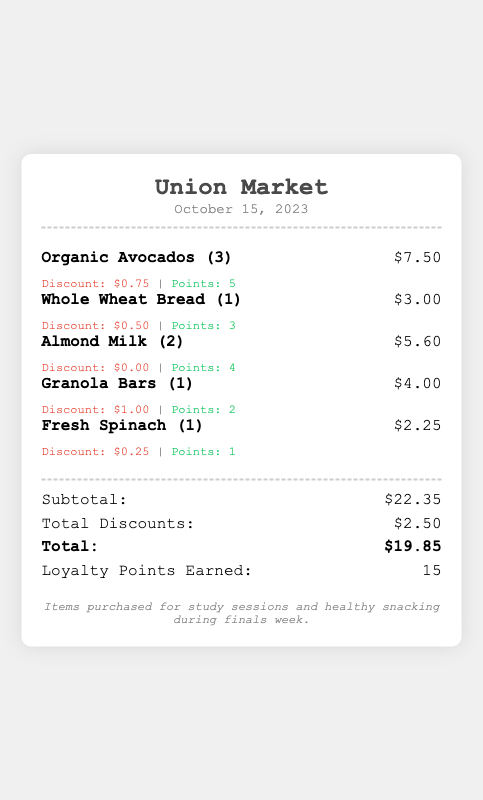What is the store name? The store name is prominently displayed at the top of the receipt.
Answer: Union Market What date was the transaction made? The date is provided below the store name on the receipt.
Answer: October 15, 2023 How many Organic Avocados were purchased? The quantity of the item is indicated in parentheses next to the item name.
Answer: 3 What was the total amount of discounts applied? The total discounts are summarized in the totals section of the receipt.
Answer: $2.50 How many loyalty points were earned? The total loyalty points are also summarized in the totals section of the receipt.
Answer: 15 What is the total cost after discounts? The total cost is calculated after applying the discounts and is displayed in the totals section.
Answer: $19.85 What were the total costs before discounts? The subtotal before discounts is shown in the totals section of the receipt.
Answer: $22.35 What item had the highest individual discount? The discount amounts for each item are listed, allowing identification of the item with the highest discount.
Answer: Granola Bars For what purpose were the items purchased? The purpose of the purchase is stated at the bottom, summarizing the context of the buying decision.
Answer: study sessions and healthy snacking during finals week 